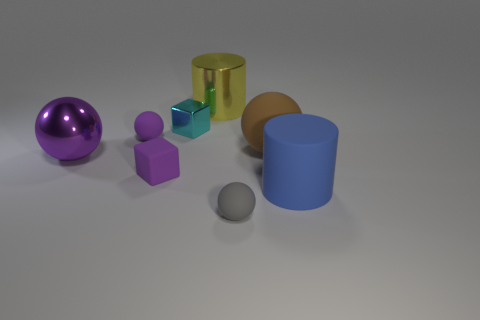What number of tiny things are both behind the purple rubber sphere and in front of the big metallic ball?
Keep it short and to the point. 0. Is there anything else that is the same shape as the big brown object?
Provide a succinct answer. Yes. Does the metal ball have the same color as the small ball that is behind the large blue matte thing?
Make the answer very short. Yes. What is the shape of the big rubber thing that is behind the small purple matte block?
Your answer should be very brief. Sphere. How many other things are the same material as the large blue cylinder?
Keep it short and to the point. 4. What material is the tiny cyan block?
Offer a terse response. Metal. How many large things are yellow matte cylinders or yellow shiny things?
Your answer should be very brief. 1. What number of cylinders are in front of the tiny purple cube?
Your response must be concise. 1. Is there a shiny object that has the same color as the rubber block?
Your response must be concise. Yes. There is a gray matte object that is the same size as the cyan cube; what is its shape?
Ensure brevity in your answer.  Sphere. 